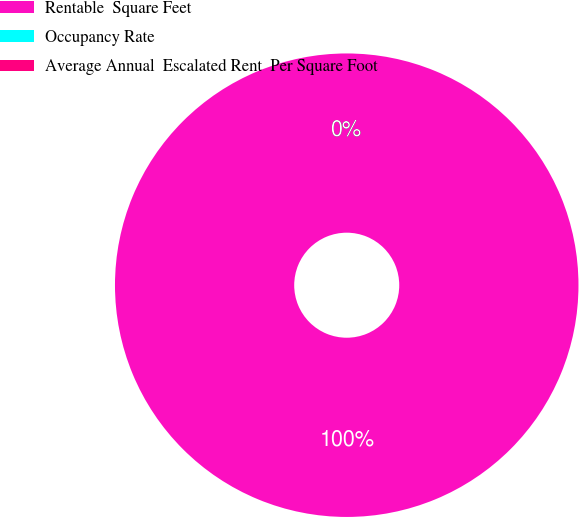<chart> <loc_0><loc_0><loc_500><loc_500><pie_chart><fcel>Rentable  Square Feet<fcel>Occupancy Rate<fcel>Average Annual  Escalated Rent  Per Square Foot<nl><fcel>100.0%<fcel>0.0%<fcel>0.0%<nl></chart> 